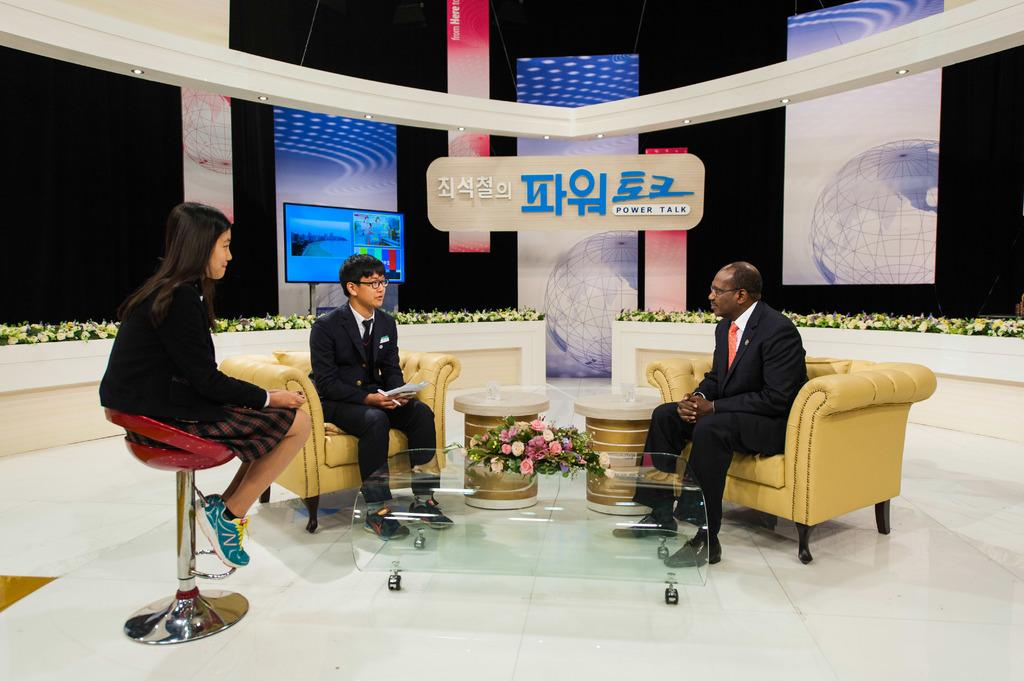What are the people in the image doing? The persons sitting at the table in the image are likely having a meal or conversation. What decorative item can be seen on the table? There is a flower vase on the table. What can be seen in the background of the image? In the background of the image, there is a television, boards, lights, and a wall. What type of creature is sitting at the table with the persons in the image? There is no creature present at the table with the persons in the image. How many additional persons are sitting at the table in the image? The number of persons sitting at the table cannot be determined from the image alone. 